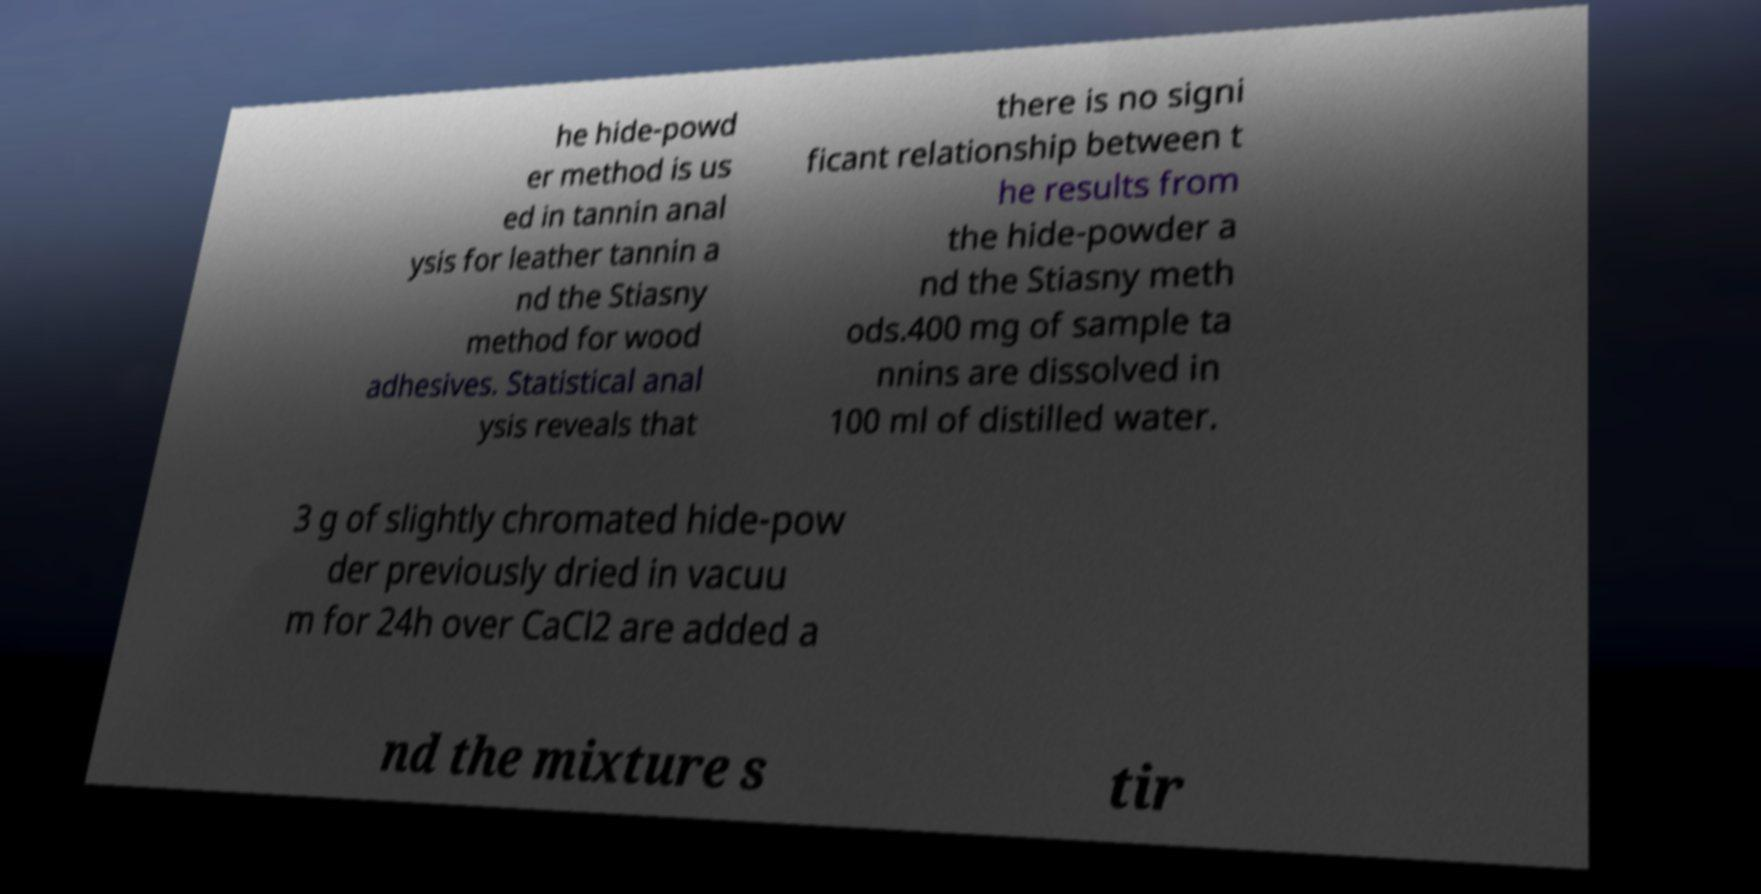Could you extract and type out the text from this image? he hide-powd er method is us ed in tannin anal ysis for leather tannin a nd the Stiasny method for wood adhesives. Statistical anal ysis reveals that there is no signi ficant relationship between t he results from the hide-powder a nd the Stiasny meth ods.400 mg of sample ta nnins are dissolved in 100 ml of distilled water. 3 g of slightly chromated hide-pow der previously dried in vacuu m for 24h over CaCl2 are added a nd the mixture s tir 